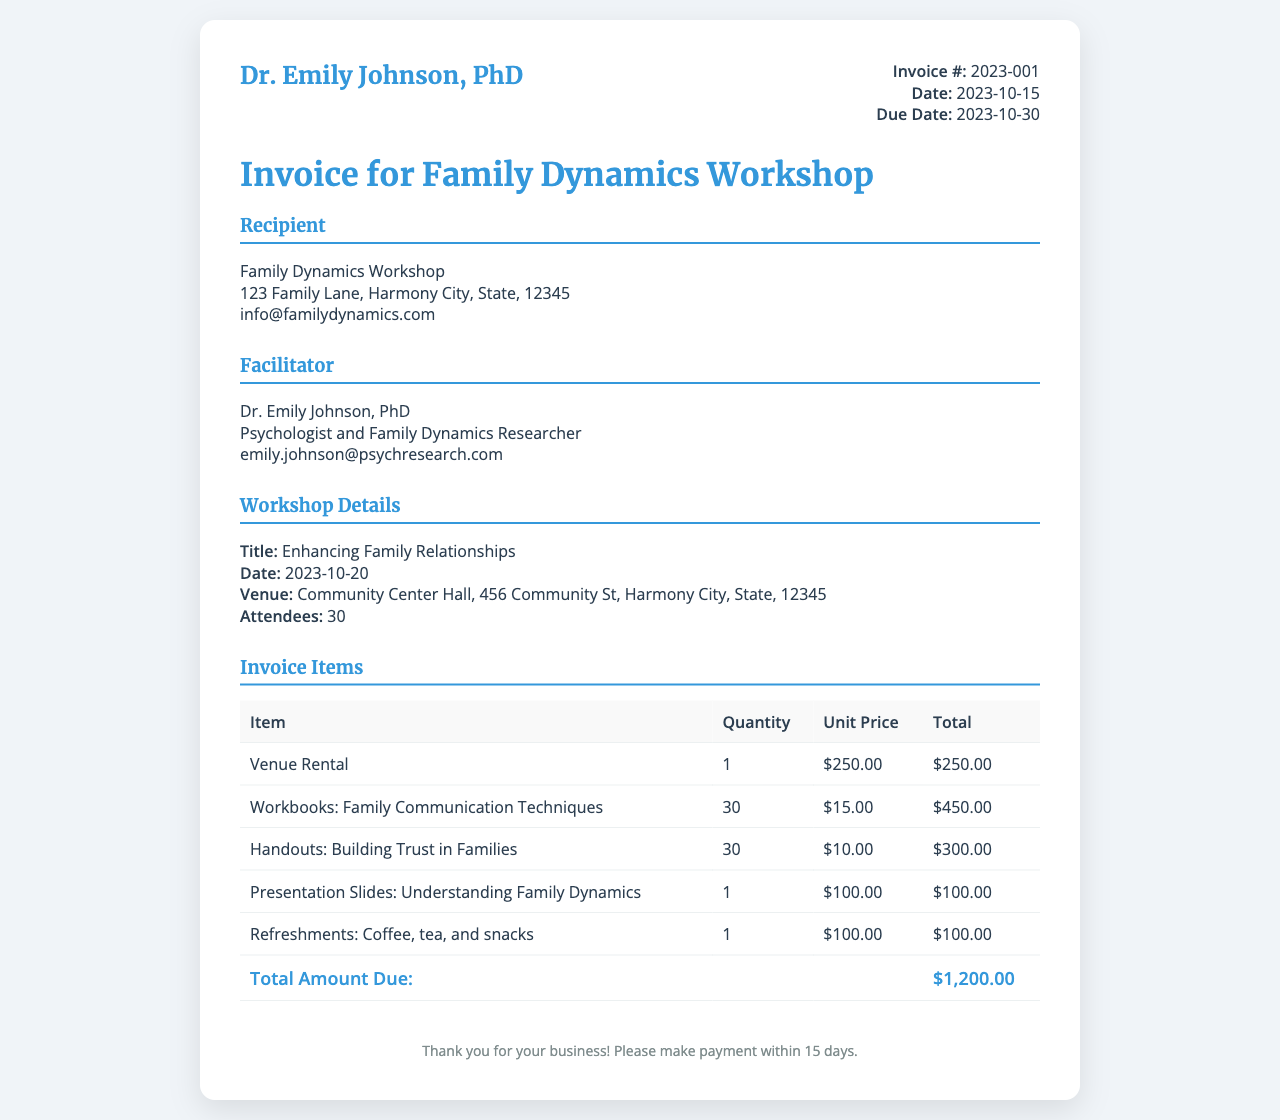What is the invoice number? The invoice number is indicated explicitly in the document as Invoice #: 2023-001.
Answer: 2023-001 What is the total amount due? The total amount due is summarized at the bottom of the invoice table as Total Amount Due: $1,200.00.
Answer: $1,200.00 How many attendees are expected at the workshop? The expected number of attendees is stated in the workshop details section as Attendees: 30.
Answer: 30 What is the venue for the workshop? The venue is specified in the workshop details, mentioning Community Center Hall, 456 Community St, Harmony City, State, 12345.
Answer: Community Center Hall What date is the workshop scheduled for? The date of the workshop is listed under workshop details as 2023-10-20.
Answer: 2023-10-20 What materials are provided for the attendees? The materials include workbooks, handouts, presentation slides, and refreshments which are detailed in the invoice items section.
Answer: Workbooks, handouts, presentation slides, and refreshments How much is charged for the venue rental? The charge for the venue rental is indicated in the invoice items table as $250.00.
Answer: $250.00 Who is the facilitator of the workshop? The facilitator is identified as Dr. Emily Johnson, PhD in the invoice under the Facilitator section.
Answer: Dr. Emily Johnson, PhD What is the due date for the invoice payment? The due date is specified clearly in the invoice details as 2023-10-30.
Answer: 2023-10-30 